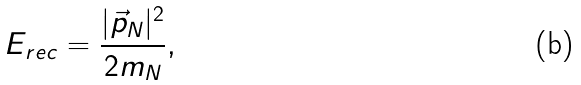Convert formula to latex. <formula><loc_0><loc_0><loc_500><loc_500>E _ { r e c } = \frac { | \vec { p } _ { N } | ^ { 2 } } { 2 m _ { N } } ,</formula> 